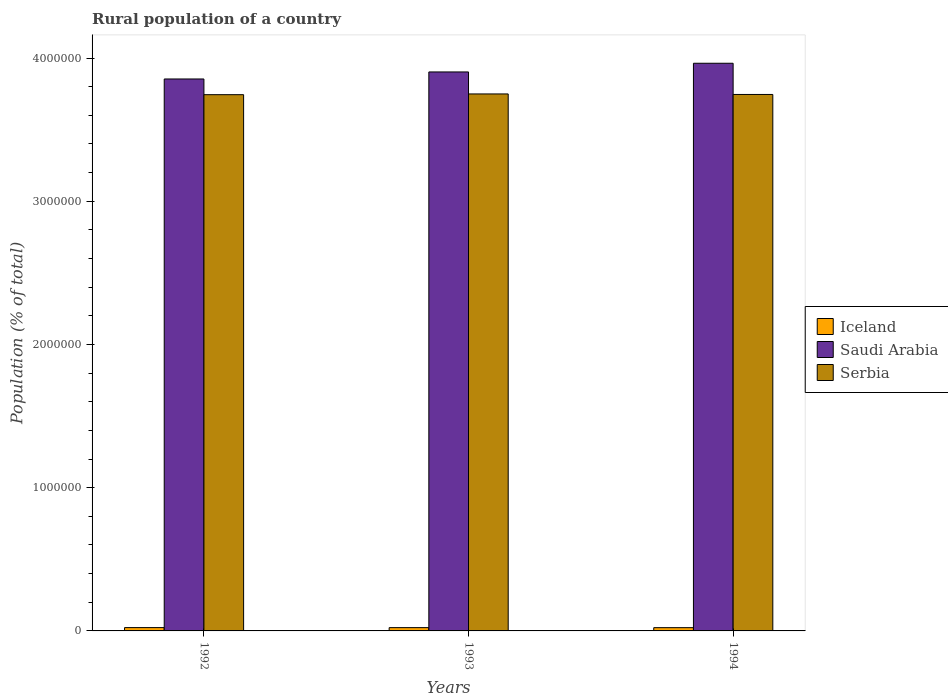How many groups of bars are there?
Offer a very short reply. 3. Are the number of bars per tick equal to the number of legend labels?
Make the answer very short. Yes. Are the number of bars on each tick of the X-axis equal?
Offer a terse response. Yes. How many bars are there on the 1st tick from the right?
Give a very brief answer. 3. What is the rural population in Iceland in 1992?
Make the answer very short. 2.32e+04. Across all years, what is the maximum rural population in Serbia?
Offer a very short reply. 3.75e+06. Across all years, what is the minimum rural population in Iceland?
Make the answer very short. 2.27e+04. What is the total rural population in Iceland in the graph?
Provide a succinct answer. 6.89e+04. What is the difference between the rural population in Iceland in 1993 and that in 1994?
Offer a very short reply. 260. What is the difference between the rural population in Iceland in 1993 and the rural population in Saudi Arabia in 1994?
Offer a terse response. -3.94e+06. What is the average rural population in Saudi Arabia per year?
Your response must be concise. 3.91e+06. In the year 1994, what is the difference between the rural population in Iceland and rural population in Saudi Arabia?
Keep it short and to the point. -3.94e+06. What is the ratio of the rural population in Serbia in 1993 to that in 1994?
Your response must be concise. 1. Is the difference between the rural population in Iceland in 1992 and 1993 greater than the difference between the rural population in Saudi Arabia in 1992 and 1993?
Offer a very short reply. Yes. What is the difference between the highest and the second highest rural population in Serbia?
Your response must be concise. 3602. What is the difference between the highest and the lowest rural population in Serbia?
Your answer should be compact. 5182. Is the sum of the rural population in Iceland in 1993 and 1994 greater than the maximum rural population in Saudi Arabia across all years?
Keep it short and to the point. No. What does the 2nd bar from the left in 1992 represents?
Offer a terse response. Saudi Arabia. What does the 1st bar from the right in 1992 represents?
Offer a terse response. Serbia. Is it the case that in every year, the sum of the rural population in Serbia and rural population in Iceland is greater than the rural population in Saudi Arabia?
Provide a succinct answer. No. Are all the bars in the graph horizontal?
Provide a short and direct response. No. How many years are there in the graph?
Ensure brevity in your answer.  3. What is the difference between two consecutive major ticks on the Y-axis?
Your answer should be compact. 1.00e+06. Where does the legend appear in the graph?
Your answer should be very brief. Center right. How many legend labels are there?
Your response must be concise. 3. What is the title of the graph?
Your response must be concise. Rural population of a country. What is the label or title of the X-axis?
Provide a succinct answer. Years. What is the label or title of the Y-axis?
Give a very brief answer. Population (% of total). What is the Population (% of total) in Iceland in 1992?
Provide a short and direct response. 2.32e+04. What is the Population (% of total) in Saudi Arabia in 1992?
Your response must be concise. 3.85e+06. What is the Population (% of total) in Serbia in 1992?
Ensure brevity in your answer.  3.74e+06. What is the Population (% of total) in Iceland in 1993?
Keep it short and to the point. 2.30e+04. What is the Population (% of total) of Saudi Arabia in 1993?
Make the answer very short. 3.90e+06. What is the Population (% of total) of Serbia in 1993?
Offer a terse response. 3.75e+06. What is the Population (% of total) of Iceland in 1994?
Keep it short and to the point. 2.27e+04. What is the Population (% of total) in Saudi Arabia in 1994?
Make the answer very short. 3.96e+06. What is the Population (% of total) in Serbia in 1994?
Your response must be concise. 3.75e+06. Across all years, what is the maximum Population (% of total) of Iceland?
Offer a very short reply. 2.32e+04. Across all years, what is the maximum Population (% of total) of Saudi Arabia?
Your answer should be very brief. 3.96e+06. Across all years, what is the maximum Population (% of total) of Serbia?
Offer a very short reply. 3.75e+06. Across all years, what is the minimum Population (% of total) of Iceland?
Provide a short and direct response. 2.27e+04. Across all years, what is the minimum Population (% of total) in Saudi Arabia?
Give a very brief answer. 3.85e+06. Across all years, what is the minimum Population (% of total) of Serbia?
Your answer should be compact. 3.74e+06. What is the total Population (% of total) of Iceland in the graph?
Make the answer very short. 6.89e+04. What is the total Population (% of total) of Saudi Arabia in the graph?
Make the answer very short. 1.17e+07. What is the total Population (% of total) in Serbia in the graph?
Your answer should be compact. 1.12e+07. What is the difference between the Population (% of total) of Iceland in 1992 and that in 1993?
Provide a succinct answer. 225. What is the difference between the Population (% of total) of Saudi Arabia in 1992 and that in 1993?
Your answer should be compact. -4.90e+04. What is the difference between the Population (% of total) in Serbia in 1992 and that in 1993?
Your answer should be very brief. -5182. What is the difference between the Population (% of total) of Iceland in 1992 and that in 1994?
Your answer should be compact. 485. What is the difference between the Population (% of total) of Saudi Arabia in 1992 and that in 1994?
Offer a terse response. -1.10e+05. What is the difference between the Population (% of total) in Serbia in 1992 and that in 1994?
Your answer should be compact. -1580. What is the difference between the Population (% of total) of Iceland in 1993 and that in 1994?
Offer a very short reply. 260. What is the difference between the Population (% of total) in Saudi Arabia in 1993 and that in 1994?
Give a very brief answer. -6.07e+04. What is the difference between the Population (% of total) of Serbia in 1993 and that in 1994?
Ensure brevity in your answer.  3602. What is the difference between the Population (% of total) in Iceland in 1992 and the Population (% of total) in Saudi Arabia in 1993?
Offer a very short reply. -3.88e+06. What is the difference between the Population (% of total) in Iceland in 1992 and the Population (% of total) in Serbia in 1993?
Provide a succinct answer. -3.73e+06. What is the difference between the Population (% of total) of Saudi Arabia in 1992 and the Population (% of total) of Serbia in 1993?
Provide a succinct answer. 1.04e+05. What is the difference between the Population (% of total) in Iceland in 1992 and the Population (% of total) in Saudi Arabia in 1994?
Provide a succinct answer. -3.94e+06. What is the difference between the Population (% of total) in Iceland in 1992 and the Population (% of total) in Serbia in 1994?
Your response must be concise. -3.72e+06. What is the difference between the Population (% of total) in Saudi Arabia in 1992 and the Population (% of total) in Serbia in 1994?
Offer a terse response. 1.08e+05. What is the difference between the Population (% of total) of Iceland in 1993 and the Population (% of total) of Saudi Arabia in 1994?
Keep it short and to the point. -3.94e+06. What is the difference between the Population (% of total) in Iceland in 1993 and the Population (% of total) in Serbia in 1994?
Keep it short and to the point. -3.72e+06. What is the difference between the Population (% of total) in Saudi Arabia in 1993 and the Population (% of total) in Serbia in 1994?
Give a very brief answer. 1.57e+05. What is the average Population (% of total) in Iceland per year?
Offer a very short reply. 2.30e+04. What is the average Population (% of total) of Saudi Arabia per year?
Offer a very short reply. 3.91e+06. What is the average Population (% of total) in Serbia per year?
Keep it short and to the point. 3.75e+06. In the year 1992, what is the difference between the Population (% of total) of Iceland and Population (% of total) of Saudi Arabia?
Provide a succinct answer. -3.83e+06. In the year 1992, what is the difference between the Population (% of total) of Iceland and Population (% of total) of Serbia?
Your response must be concise. -3.72e+06. In the year 1992, what is the difference between the Population (% of total) in Saudi Arabia and Population (% of total) in Serbia?
Your answer should be compact. 1.10e+05. In the year 1993, what is the difference between the Population (% of total) of Iceland and Population (% of total) of Saudi Arabia?
Your answer should be very brief. -3.88e+06. In the year 1993, what is the difference between the Population (% of total) in Iceland and Population (% of total) in Serbia?
Provide a succinct answer. -3.73e+06. In the year 1993, what is the difference between the Population (% of total) in Saudi Arabia and Population (% of total) in Serbia?
Offer a terse response. 1.54e+05. In the year 1994, what is the difference between the Population (% of total) in Iceland and Population (% of total) in Saudi Arabia?
Offer a terse response. -3.94e+06. In the year 1994, what is the difference between the Population (% of total) of Iceland and Population (% of total) of Serbia?
Provide a short and direct response. -3.72e+06. In the year 1994, what is the difference between the Population (% of total) in Saudi Arabia and Population (% of total) in Serbia?
Give a very brief answer. 2.18e+05. What is the ratio of the Population (% of total) of Iceland in 1992 to that in 1993?
Offer a terse response. 1.01. What is the ratio of the Population (% of total) in Saudi Arabia in 1992 to that in 1993?
Give a very brief answer. 0.99. What is the ratio of the Population (% of total) in Iceland in 1992 to that in 1994?
Your answer should be compact. 1.02. What is the ratio of the Population (% of total) of Saudi Arabia in 1992 to that in 1994?
Offer a terse response. 0.97. What is the ratio of the Population (% of total) in Iceland in 1993 to that in 1994?
Offer a terse response. 1.01. What is the ratio of the Population (% of total) in Saudi Arabia in 1993 to that in 1994?
Offer a very short reply. 0.98. What is the difference between the highest and the second highest Population (% of total) in Iceland?
Make the answer very short. 225. What is the difference between the highest and the second highest Population (% of total) of Saudi Arabia?
Provide a short and direct response. 6.07e+04. What is the difference between the highest and the second highest Population (% of total) in Serbia?
Offer a terse response. 3602. What is the difference between the highest and the lowest Population (% of total) of Iceland?
Offer a terse response. 485. What is the difference between the highest and the lowest Population (% of total) of Saudi Arabia?
Provide a short and direct response. 1.10e+05. What is the difference between the highest and the lowest Population (% of total) of Serbia?
Provide a short and direct response. 5182. 